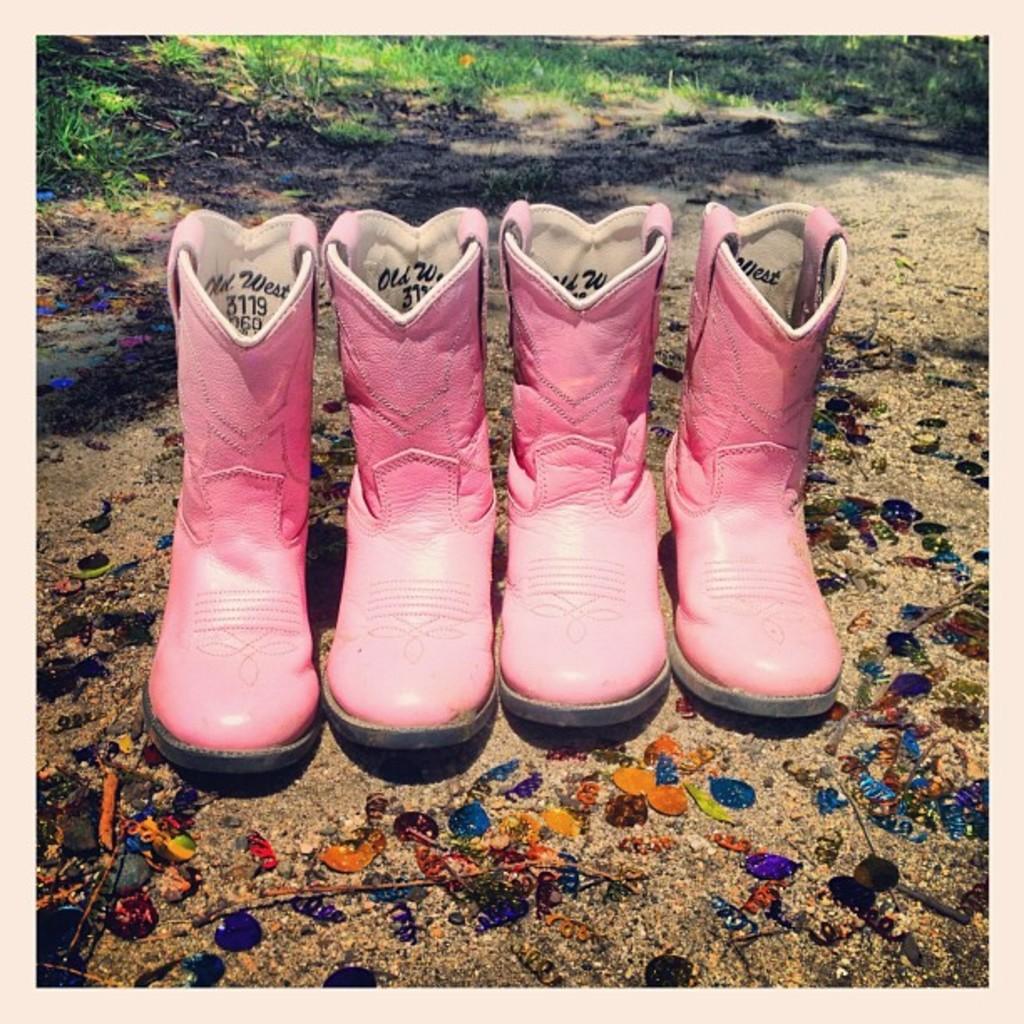Can you describe this image briefly? In the picture we can see two pairs of pink color shoes with some designs on it which are placed on the path and on the path we can see some colored stones and in the background we can see some part of grass surface. 